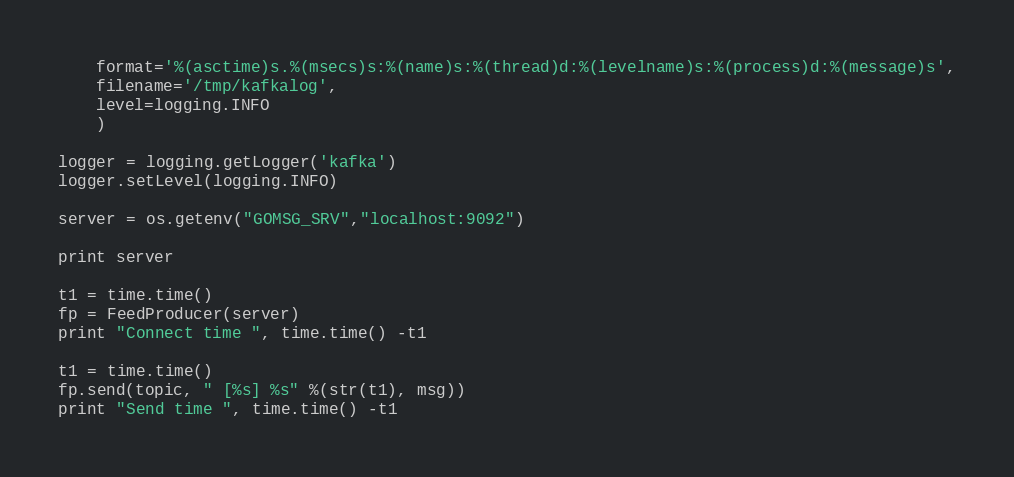<code> <loc_0><loc_0><loc_500><loc_500><_Python_>    format='%(asctime)s.%(msecs)s:%(name)s:%(thread)d:%(levelname)s:%(process)d:%(message)s',
    filename='/tmp/kafkalog',
    level=logging.INFO
    )

logger = logging.getLogger('kafka')
logger.setLevel(logging.INFO)

server = os.getenv("GOMSG_SRV","localhost:9092")

print server

t1 = time.time()
fp = FeedProducer(server)
print "Connect time ", time.time() -t1

t1 = time.time()
fp.send(topic, " [%s] %s" %(str(t1), msg))
print "Send time ", time.time() -t1

</code> 